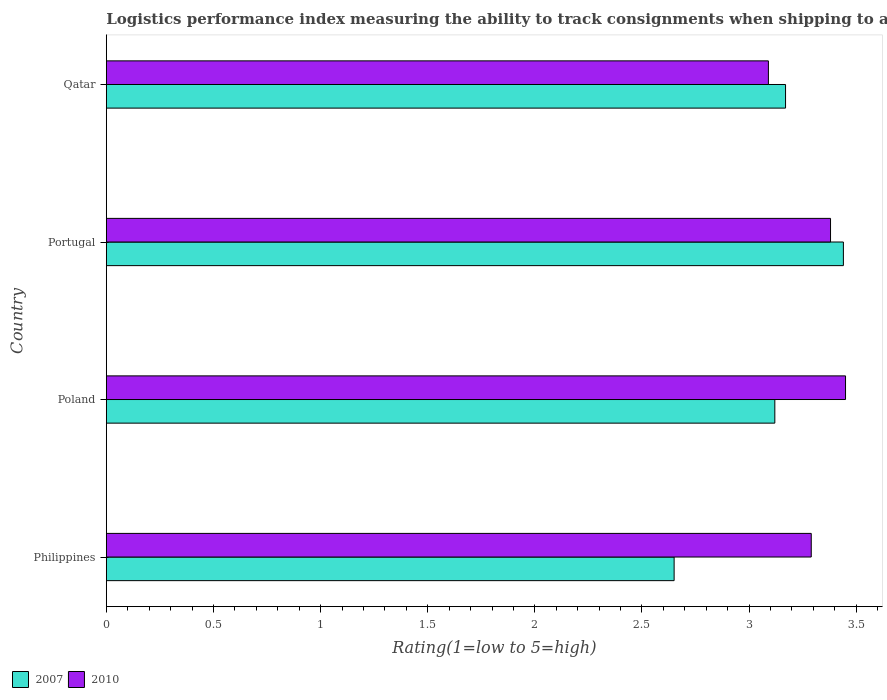How many different coloured bars are there?
Your answer should be very brief. 2. What is the label of the 3rd group of bars from the top?
Provide a succinct answer. Poland. What is the Logistic performance index in 2010 in Poland?
Your response must be concise. 3.45. Across all countries, what is the maximum Logistic performance index in 2010?
Offer a very short reply. 3.45. Across all countries, what is the minimum Logistic performance index in 2007?
Give a very brief answer. 2.65. In which country was the Logistic performance index in 2007 maximum?
Ensure brevity in your answer.  Portugal. In which country was the Logistic performance index in 2010 minimum?
Your answer should be compact. Qatar. What is the total Logistic performance index in 2010 in the graph?
Offer a terse response. 13.21. What is the difference between the Logistic performance index in 2007 in Portugal and that in Qatar?
Offer a very short reply. 0.27. What is the difference between the Logistic performance index in 2010 in Portugal and the Logistic performance index in 2007 in Qatar?
Your response must be concise. 0.21. What is the average Logistic performance index in 2007 per country?
Make the answer very short. 3.09. What is the difference between the Logistic performance index in 2007 and Logistic performance index in 2010 in Qatar?
Give a very brief answer. 0.08. What is the ratio of the Logistic performance index in 2010 in Poland to that in Qatar?
Your answer should be very brief. 1.12. Is the Logistic performance index in 2010 in Portugal less than that in Qatar?
Provide a succinct answer. No. What is the difference between the highest and the second highest Logistic performance index in 2010?
Your answer should be compact. 0.07. What is the difference between the highest and the lowest Logistic performance index in 2007?
Provide a succinct answer. 0.79. In how many countries, is the Logistic performance index in 2007 greater than the average Logistic performance index in 2007 taken over all countries?
Offer a very short reply. 3. Is the sum of the Logistic performance index in 2007 in Poland and Portugal greater than the maximum Logistic performance index in 2010 across all countries?
Offer a terse response. Yes. What does the 2nd bar from the bottom in Philippines represents?
Offer a very short reply. 2010. How many countries are there in the graph?
Provide a succinct answer. 4. What is the difference between two consecutive major ticks on the X-axis?
Give a very brief answer. 0.5. Does the graph contain any zero values?
Your response must be concise. No. Where does the legend appear in the graph?
Provide a short and direct response. Bottom left. What is the title of the graph?
Give a very brief answer. Logistics performance index measuring the ability to track consignments when shipping to a market. What is the label or title of the X-axis?
Your answer should be compact. Rating(1=low to 5=high). What is the Rating(1=low to 5=high) in 2007 in Philippines?
Your answer should be very brief. 2.65. What is the Rating(1=low to 5=high) in 2010 in Philippines?
Ensure brevity in your answer.  3.29. What is the Rating(1=low to 5=high) of 2007 in Poland?
Offer a terse response. 3.12. What is the Rating(1=low to 5=high) of 2010 in Poland?
Your response must be concise. 3.45. What is the Rating(1=low to 5=high) of 2007 in Portugal?
Offer a very short reply. 3.44. What is the Rating(1=low to 5=high) of 2010 in Portugal?
Offer a terse response. 3.38. What is the Rating(1=low to 5=high) of 2007 in Qatar?
Keep it short and to the point. 3.17. What is the Rating(1=low to 5=high) in 2010 in Qatar?
Keep it short and to the point. 3.09. Across all countries, what is the maximum Rating(1=low to 5=high) in 2007?
Make the answer very short. 3.44. Across all countries, what is the maximum Rating(1=low to 5=high) in 2010?
Offer a very short reply. 3.45. Across all countries, what is the minimum Rating(1=low to 5=high) of 2007?
Your answer should be compact. 2.65. Across all countries, what is the minimum Rating(1=low to 5=high) of 2010?
Make the answer very short. 3.09. What is the total Rating(1=low to 5=high) of 2007 in the graph?
Keep it short and to the point. 12.38. What is the total Rating(1=low to 5=high) of 2010 in the graph?
Keep it short and to the point. 13.21. What is the difference between the Rating(1=low to 5=high) in 2007 in Philippines and that in Poland?
Your answer should be very brief. -0.47. What is the difference between the Rating(1=low to 5=high) in 2010 in Philippines and that in Poland?
Give a very brief answer. -0.16. What is the difference between the Rating(1=low to 5=high) in 2007 in Philippines and that in Portugal?
Offer a very short reply. -0.79. What is the difference between the Rating(1=low to 5=high) in 2010 in Philippines and that in Portugal?
Your answer should be compact. -0.09. What is the difference between the Rating(1=low to 5=high) in 2007 in Philippines and that in Qatar?
Your answer should be very brief. -0.52. What is the difference between the Rating(1=low to 5=high) in 2007 in Poland and that in Portugal?
Keep it short and to the point. -0.32. What is the difference between the Rating(1=low to 5=high) in 2010 in Poland and that in Portugal?
Provide a succinct answer. 0.07. What is the difference between the Rating(1=low to 5=high) in 2010 in Poland and that in Qatar?
Give a very brief answer. 0.36. What is the difference between the Rating(1=low to 5=high) in 2007 in Portugal and that in Qatar?
Give a very brief answer. 0.27. What is the difference between the Rating(1=low to 5=high) of 2010 in Portugal and that in Qatar?
Make the answer very short. 0.29. What is the difference between the Rating(1=low to 5=high) of 2007 in Philippines and the Rating(1=low to 5=high) of 2010 in Portugal?
Offer a very short reply. -0.73. What is the difference between the Rating(1=low to 5=high) of 2007 in Philippines and the Rating(1=low to 5=high) of 2010 in Qatar?
Your answer should be very brief. -0.44. What is the difference between the Rating(1=low to 5=high) in 2007 in Poland and the Rating(1=low to 5=high) in 2010 in Portugal?
Offer a very short reply. -0.26. What is the difference between the Rating(1=low to 5=high) in 2007 in Poland and the Rating(1=low to 5=high) in 2010 in Qatar?
Your answer should be compact. 0.03. What is the average Rating(1=low to 5=high) of 2007 per country?
Keep it short and to the point. 3.1. What is the average Rating(1=low to 5=high) of 2010 per country?
Provide a short and direct response. 3.3. What is the difference between the Rating(1=low to 5=high) in 2007 and Rating(1=low to 5=high) in 2010 in Philippines?
Your answer should be compact. -0.64. What is the difference between the Rating(1=low to 5=high) in 2007 and Rating(1=low to 5=high) in 2010 in Poland?
Keep it short and to the point. -0.33. What is the ratio of the Rating(1=low to 5=high) in 2007 in Philippines to that in Poland?
Give a very brief answer. 0.85. What is the ratio of the Rating(1=low to 5=high) in 2010 in Philippines to that in Poland?
Your answer should be compact. 0.95. What is the ratio of the Rating(1=low to 5=high) in 2007 in Philippines to that in Portugal?
Offer a terse response. 0.77. What is the ratio of the Rating(1=low to 5=high) of 2010 in Philippines to that in Portugal?
Offer a very short reply. 0.97. What is the ratio of the Rating(1=low to 5=high) in 2007 in Philippines to that in Qatar?
Offer a terse response. 0.84. What is the ratio of the Rating(1=low to 5=high) of 2010 in Philippines to that in Qatar?
Keep it short and to the point. 1.06. What is the ratio of the Rating(1=low to 5=high) in 2007 in Poland to that in Portugal?
Make the answer very short. 0.91. What is the ratio of the Rating(1=low to 5=high) in 2010 in Poland to that in Portugal?
Provide a succinct answer. 1.02. What is the ratio of the Rating(1=low to 5=high) in 2007 in Poland to that in Qatar?
Ensure brevity in your answer.  0.98. What is the ratio of the Rating(1=low to 5=high) in 2010 in Poland to that in Qatar?
Give a very brief answer. 1.12. What is the ratio of the Rating(1=low to 5=high) in 2007 in Portugal to that in Qatar?
Offer a terse response. 1.09. What is the ratio of the Rating(1=low to 5=high) in 2010 in Portugal to that in Qatar?
Ensure brevity in your answer.  1.09. What is the difference between the highest and the second highest Rating(1=low to 5=high) of 2007?
Your answer should be very brief. 0.27. What is the difference between the highest and the second highest Rating(1=low to 5=high) in 2010?
Your response must be concise. 0.07. What is the difference between the highest and the lowest Rating(1=low to 5=high) of 2007?
Your response must be concise. 0.79. What is the difference between the highest and the lowest Rating(1=low to 5=high) in 2010?
Ensure brevity in your answer.  0.36. 